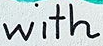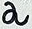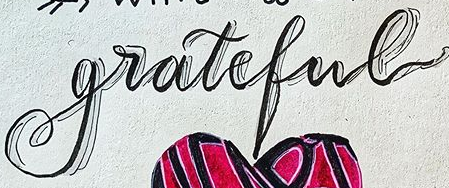What text is displayed in these images sequentially, separated by a semicolon? with; a; grateful 